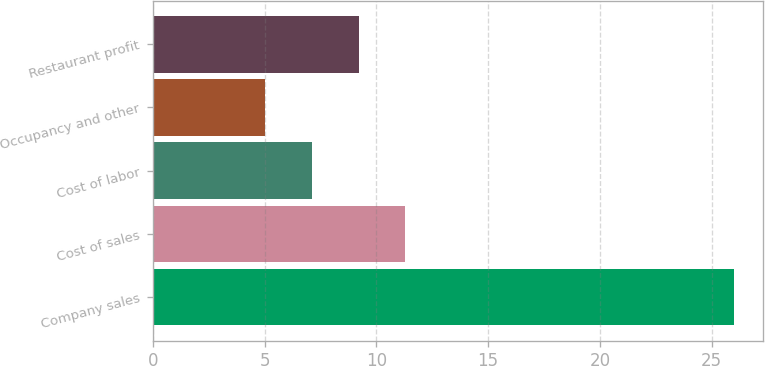<chart> <loc_0><loc_0><loc_500><loc_500><bar_chart><fcel>Company sales<fcel>Cost of sales<fcel>Cost of labor<fcel>Occupancy and other<fcel>Restaurant profit<nl><fcel>26<fcel>11.3<fcel>7.1<fcel>5<fcel>9.2<nl></chart> 